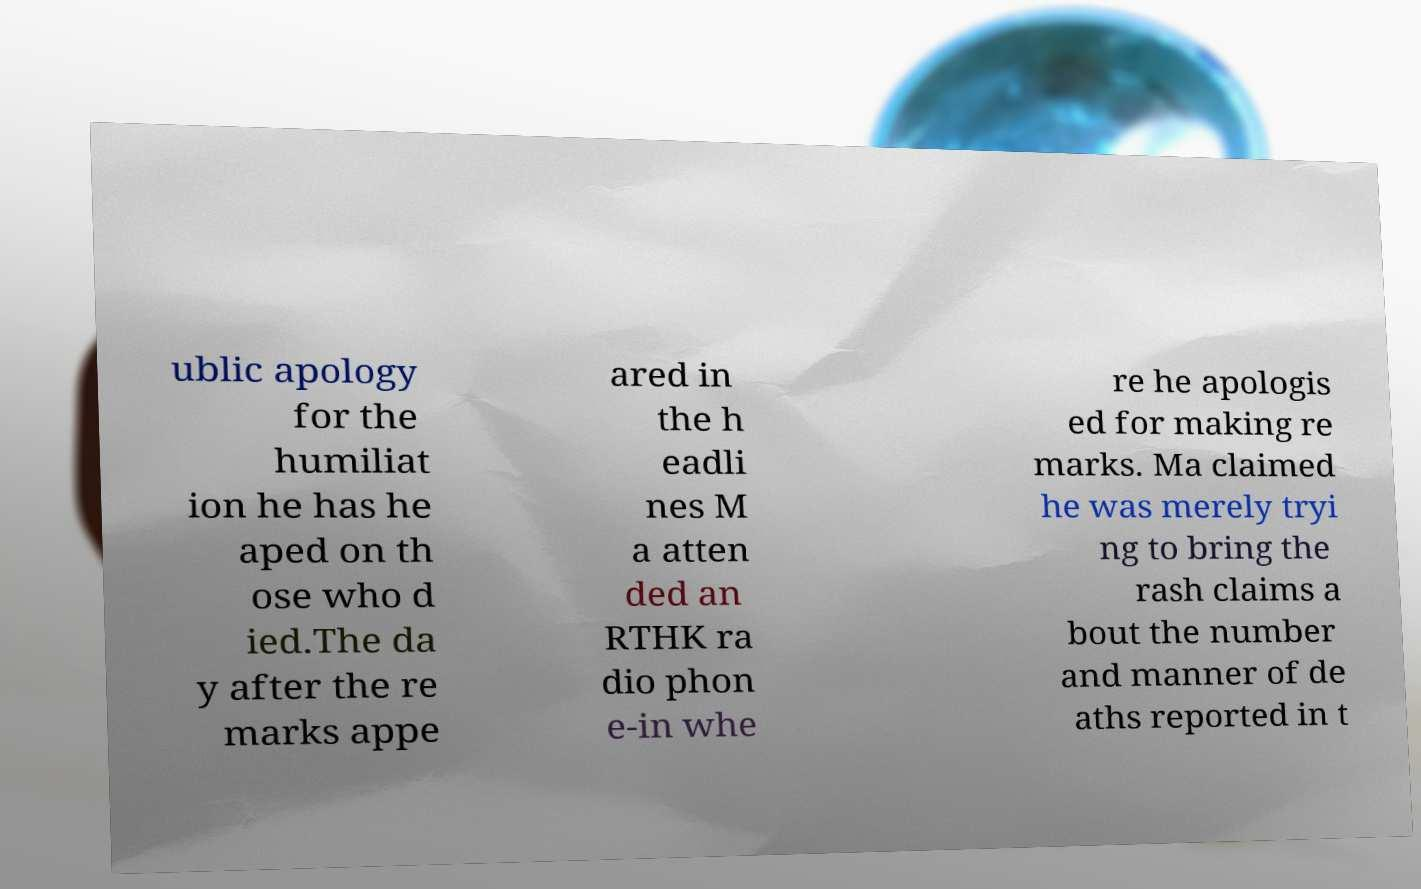Please read and relay the text visible in this image. What does it say? ublic apology for the humiliat ion he has he aped on th ose who d ied.The da y after the re marks appe ared in the h eadli nes M a atten ded an RTHK ra dio phon e-in whe re he apologis ed for making re marks. Ma claimed he was merely tryi ng to bring the rash claims a bout the number and manner of de aths reported in t 